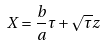Convert formula to latex. <formula><loc_0><loc_0><loc_500><loc_500>X = \frac { b } { a } \tau + \sqrt { \tau } z</formula> 